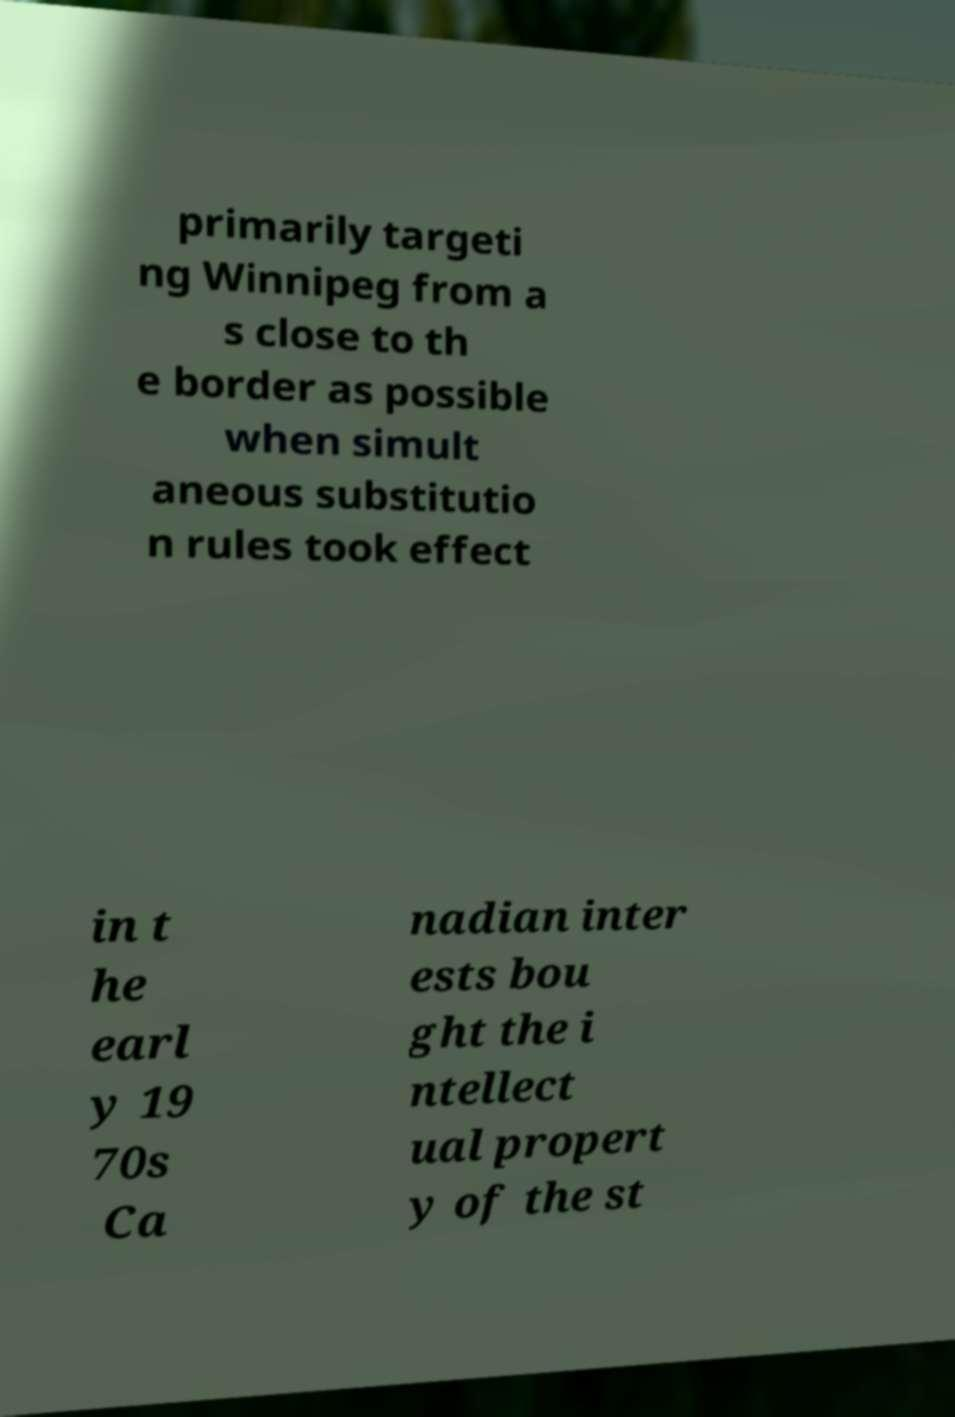Could you assist in decoding the text presented in this image and type it out clearly? primarily targeti ng Winnipeg from a s close to th e border as possible when simult aneous substitutio n rules took effect in t he earl y 19 70s Ca nadian inter ests bou ght the i ntellect ual propert y of the st 